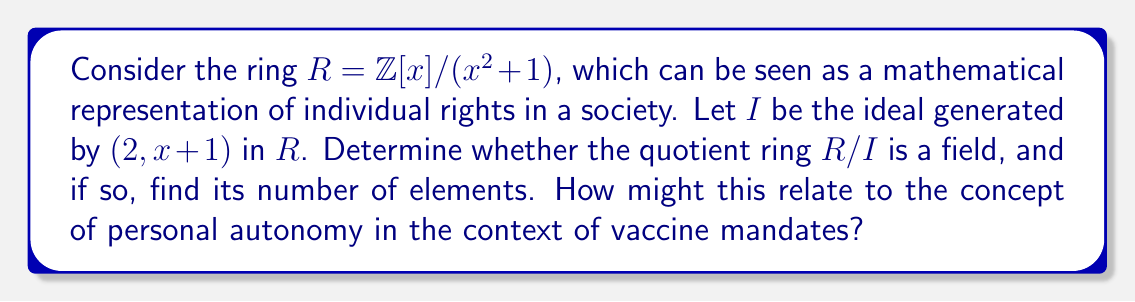Could you help me with this problem? To analyze the properties of the quotient ring $R/I$, we'll follow these steps:

1) First, note that $R = \mathbb{Z}[x]/(x^2 + 1)$ is isomorphic to the Gaussian integers $\mathbb{Z}[i]$.

2) The ideal $I$ is generated by $(2, x+1)$. In $\mathbb{Z}[i]$, this corresponds to the ideal generated by $2$ and $1+i$.

3) To determine if $R/I$ is a field, we need to check if $I$ is a maximal ideal in $R$.

4) Consider the norm of $1+i$ in $\mathbb{Z}[i]$:
   $N(1+i) = (1+i)(1-i) = 1^2 + 1^2 = 2$

5) This means that $2$ and $1+i$ generate the same ideal in $\mathbb{Z}[i]$, which is $(1+i)$.

6) The quotient ring $\mathbb{Z}[i]/(1+i)$ is isomorphic to $\mathbb{Z}/2\mathbb{Z}$, which is the field $\mathbb{F}_2$.

7) Since $\mathbb{F}_2$ is a field, $I$ is indeed a maximal ideal in $R$, and thus $R/I$ is a field.

8) $\mathbb{F}_2$ has exactly 2 elements: $\{0, 1\}$.

In the context of vaccine mandates and personal autonomy, this mathematical structure could be interpreted as follows:
- The ring $R$ represents the space of individual rights and choices.
- The ideal $I$ represents the restrictions imposed by vaccine mandates.
- The quotient ring $R/I$ being a field with only two elements could symbolize the limited choices left to individuals under strict mandates: comply or face consequences.
Answer: Yes, $R/I$ is a field, and it has 2 elements. 